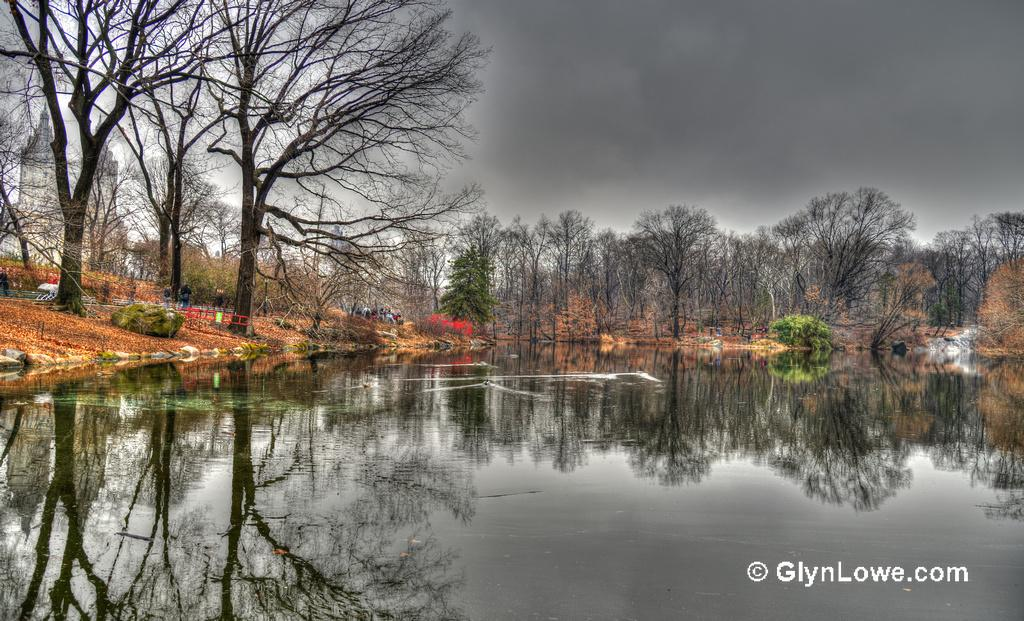What is one of the natural elements present in the image? There is water in the image. What type of vegetation can be seen in the image? There are trees in the image. What type of man-made structures are visible in the image? There are buildings in the image. What can be seen in the sky in the image? There are clouds in the image. Where is the text located in the image? The text is in the bottom right-hand corner of the image. What is the feeling of the hand holding the camera that took the image? There is no hand or camera mentioned in the image, so it is not possible to determine the feeling of the hand. 